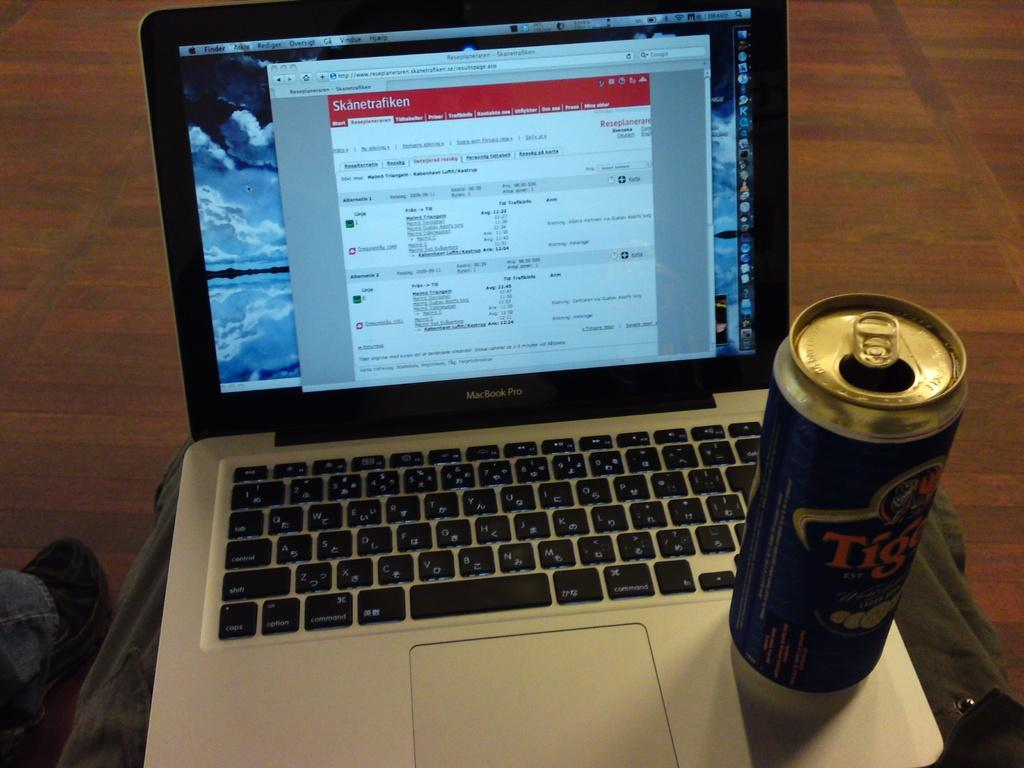<image>
Render a clear and concise summary of the photo. A laptop computer open to a page titled Skanetrafiken with an open beer sitting on it 